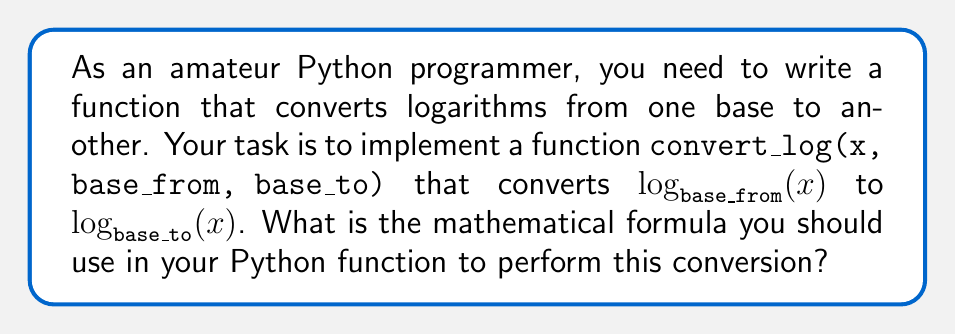What is the answer to this math problem? To convert between logarithms of different bases, we can use the change of base formula. This formula states that for any positive number $x$ and any positive bases $a$ and $b$ (where $a \neq 1$ and $b \neq 1$):

$$\log_b(x) = \frac{\log_a(x)}{\log_a(b)}$$

In our case:
- $x$ is the number we're taking the logarithm of
- $a$ is the original base (base_from)
- $b$ is the new base (base_to)

So, to convert $\log_{base\_from}(x)$ to $\log_{base\_to}(x)$, we can use:

$$\log_{base\_to}(x) = \frac{\log_{base\_from}(x)}{\log_{base\_from}(base\_to)}$$

In Python, we usually work with natural logarithms (base $e$) or common logarithms (base 10). The `math` module provides `log()` for natural logarithms and `log10()` for common logarithms. We can use these to implement our conversion function.

The Python implementation would look like this:

```python
import math

def convert_log(x, base_from, base_to):
    return math.log(x, base_from) / math.log(base_to, base_from)
```

This function uses the `math.log(x, base)` function, which computes the logarithm of x with the given base. If we omit the base, it defaults to the natural logarithm.
Answer: The mathematical formula to convert $\log_{base\_from}(x)$ to $\log_{base\_to}(x)$ is:

$$\log_{base\_to}(x) = \frac{\log_{base\_from}(x)}{\log_{base\_from}(base\_to)}$$ 